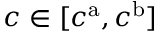Convert formula to latex. <formula><loc_0><loc_0><loc_500><loc_500>c \in [ c ^ { a } , c ^ { b } ]</formula> 